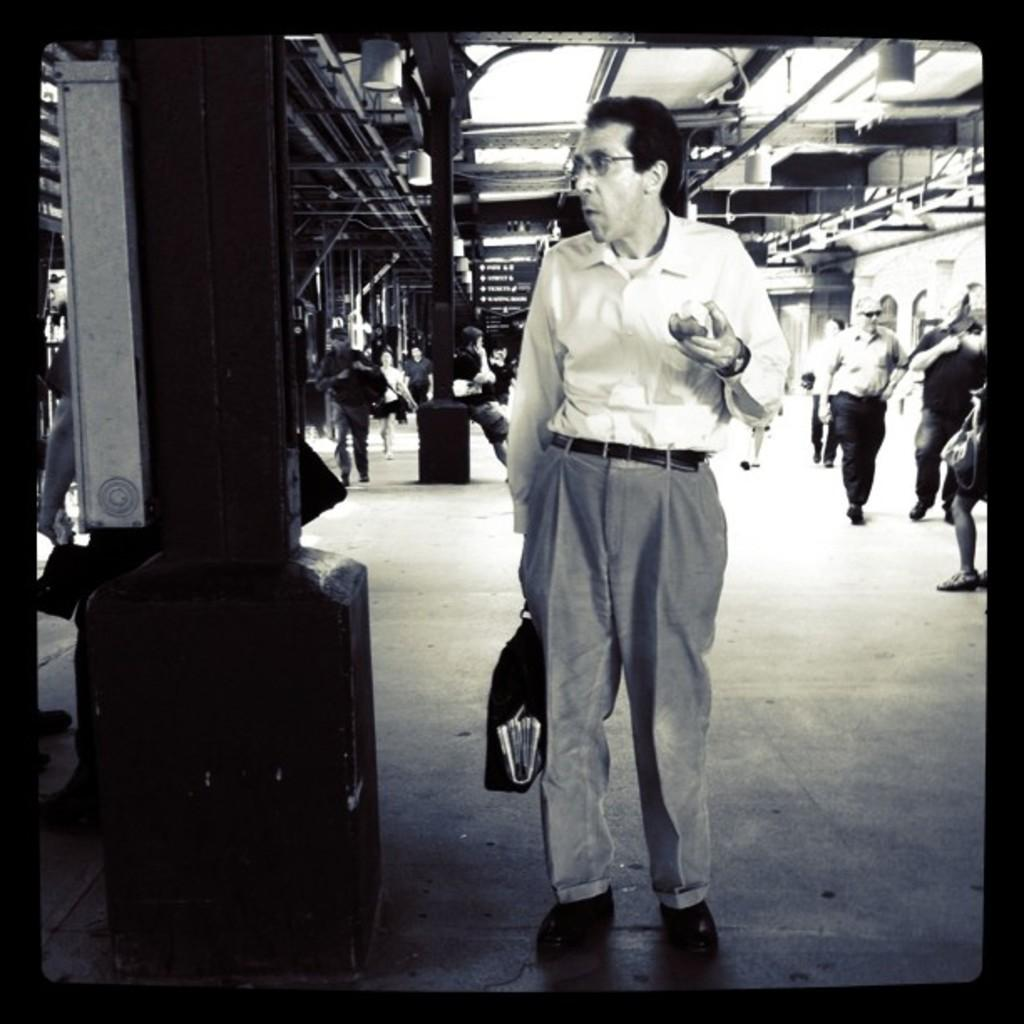What is the color scheme of the image? The image is black and white. What are the people in the image doing? There are persons sitting and walking in the image. What can be seen on the ground in the image? The floor is visible in the image. What is present in the background of the image? There are grills and poles in the background of the image. What type of plough can be seen being used by the servant in the image? There is no plough or servant present in the image. What is the location of the image, specifically in relation to downtown? The location of the image is not specified, and there is no mention of downtown. 